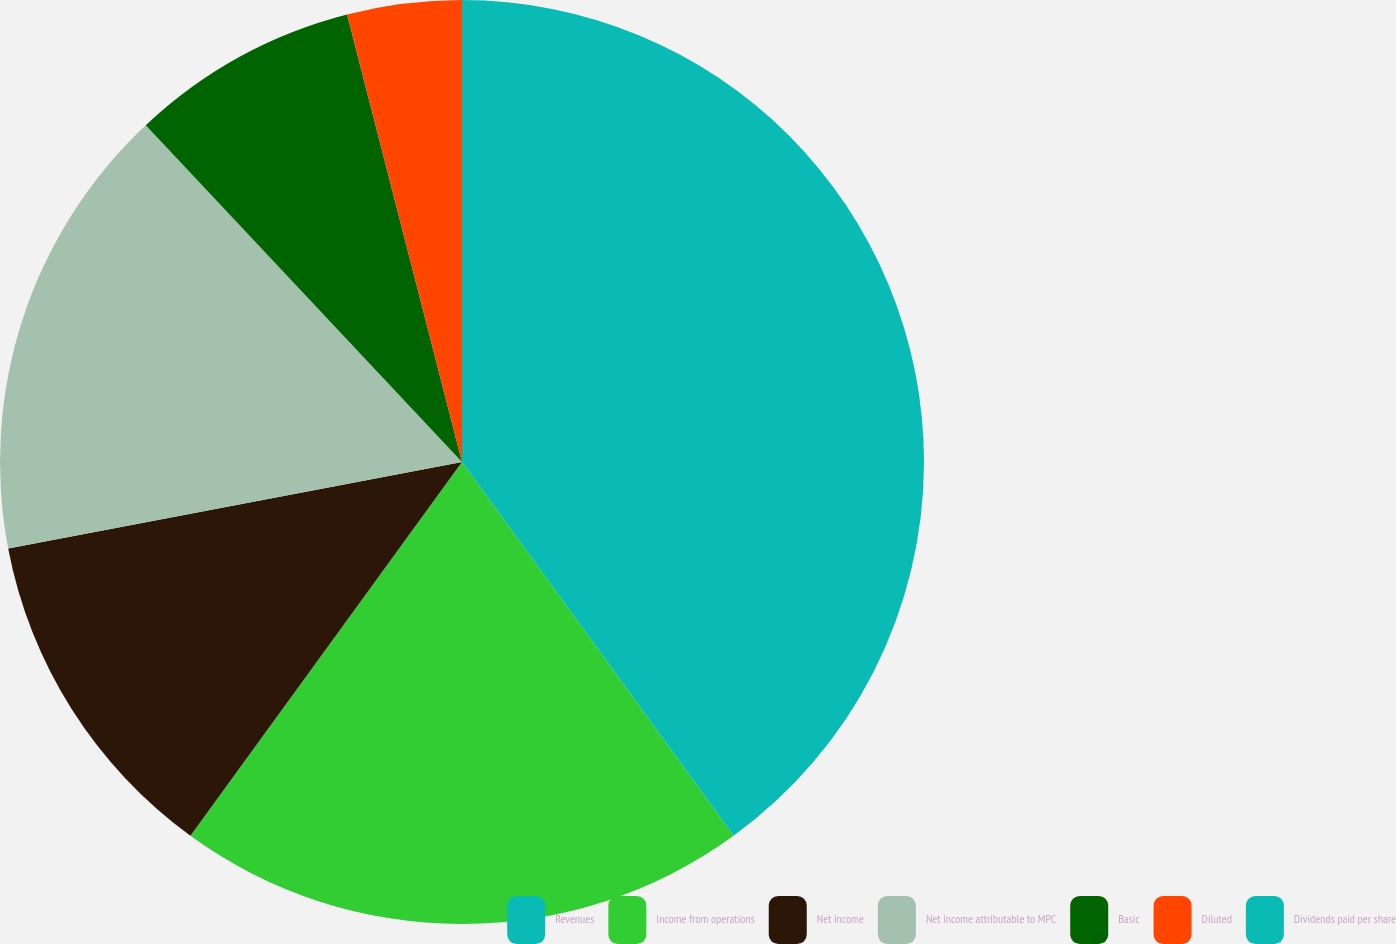Convert chart to OTSL. <chart><loc_0><loc_0><loc_500><loc_500><pie_chart><fcel>Revenues<fcel>Income from operations<fcel>Net income<fcel>Net income attributable to MPC<fcel>Basic<fcel>Diluted<fcel>Dividends paid per share<nl><fcel>40.0%<fcel>20.0%<fcel>12.0%<fcel>16.0%<fcel>8.0%<fcel>4.0%<fcel>0.0%<nl></chart> 